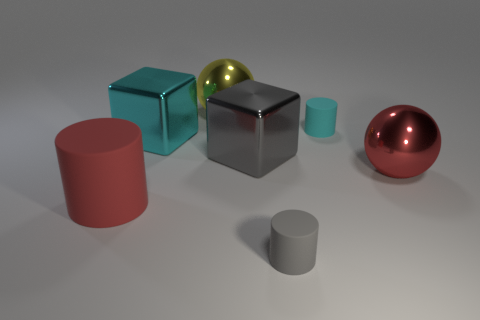What is the material of the other thing that is the same color as the big matte thing?
Provide a succinct answer. Metal. There is a large cylinder; is its color the same as the large sphere that is in front of the big yellow sphere?
Keep it short and to the point. Yes. What material is the red object that is right of the gray rubber cylinder?
Make the answer very short. Metal. Are there any tiny rubber cylinders of the same color as the big cylinder?
Offer a terse response. No. The rubber object that is the same size as the cyan shiny cube is what color?
Offer a very short reply. Red. How many large things are gray metallic objects or purple metal spheres?
Make the answer very short. 1. Are there an equal number of large yellow spheres right of the large yellow metal object and yellow spheres right of the gray rubber thing?
Offer a terse response. Yes. How many cyan objects are the same size as the red sphere?
Provide a short and direct response. 1. What number of yellow things are either small matte cylinders or large metal spheres?
Your answer should be very brief. 1. Are there an equal number of big metal blocks in front of the gray shiny block and cyan rubber things?
Offer a terse response. No. 